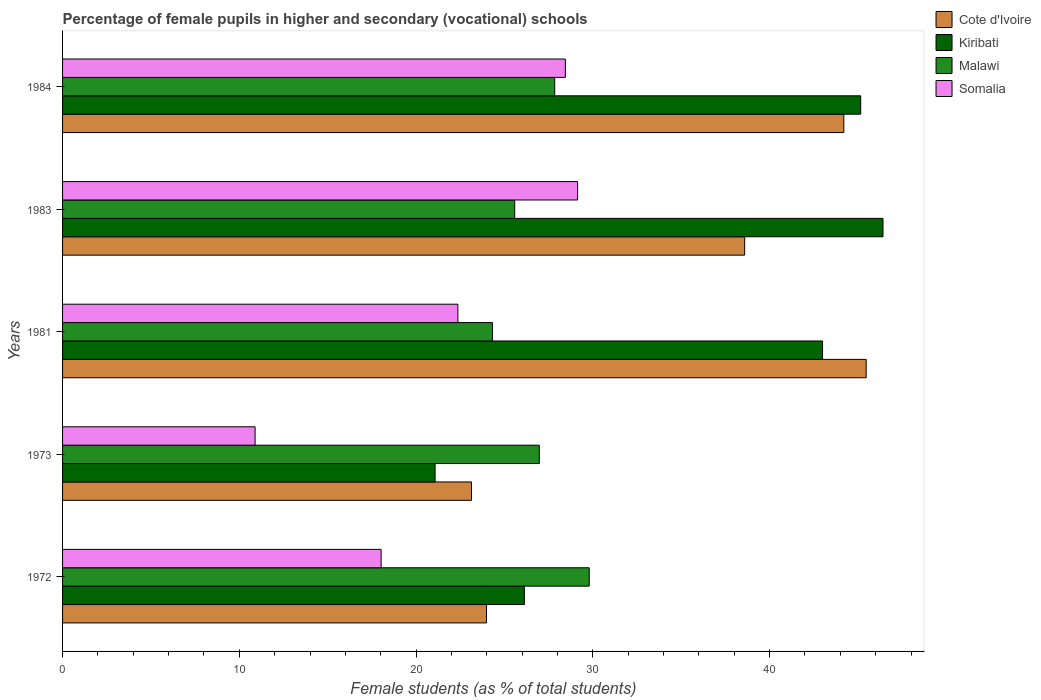How many different coloured bars are there?
Provide a short and direct response. 4. Are the number of bars on each tick of the Y-axis equal?
Ensure brevity in your answer.  Yes. How many bars are there on the 3rd tick from the top?
Provide a short and direct response. 4. How many bars are there on the 3rd tick from the bottom?
Provide a succinct answer. 4. What is the percentage of female pupils in higher and secondary schools in Kiribati in 1981?
Your answer should be compact. 43. Across all years, what is the maximum percentage of female pupils in higher and secondary schools in Kiribati?
Offer a terse response. 46.42. Across all years, what is the minimum percentage of female pupils in higher and secondary schools in Somalia?
Your answer should be very brief. 10.89. What is the total percentage of female pupils in higher and secondary schools in Somalia in the graph?
Your answer should be very brief. 108.86. What is the difference between the percentage of female pupils in higher and secondary schools in Somalia in 1972 and that in 1983?
Ensure brevity in your answer.  -11.12. What is the difference between the percentage of female pupils in higher and secondary schools in Kiribati in 1973 and the percentage of female pupils in higher and secondary schools in Cote d'Ivoire in 1972?
Make the answer very short. -2.91. What is the average percentage of female pupils in higher and secondary schools in Somalia per year?
Offer a very short reply. 21.77. In the year 1973, what is the difference between the percentage of female pupils in higher and secondary schools in Cote d'Ivoire and percentage of female pupils in higher and secondary schools in Somalia?
Provide a succinct answer. 12.24. What is the ratio of the percentage of female pupils in higher and secondary schools in Cote d'Ivoire in 1973 to that in 1981?
Make the answer very short. 0.51. What is the difference between the highest and the second highest percentage of female pupils in higher and secondary schools in Cote d'Ivoire?
Keep it short and to the point. 1.26. What is the difference between the highest and the lowest percentage of female pupils in higher and secondary schools in Kiribati?
Make the answer very short. 25.34. What does the 1st bar from the top in 1981 represents?
Make the answer very short. Somalia. What does the 1st bar from the bottom in 1981 represents?
Make the answer very short. Cote d'Ivoire. Is it the case that in every year, the sum of the percentage of female pupils in higher and secondary schools in Cote d'Ivoire and percentage of female pupils in higher and secondary schools in Somalia is greater than the percentage of female pupils in higher and secondary schools in Malawi?
Your response must be concise. Yes. How many bars are there?
Keep it short and to the point. 20. How many years are there in the graph?
Provide a short and direct response. 5. Are the values on the major ticks of X-axis written in scientific E-notation?
Keep it short and to the point. No. Does the graph contain any zero values?
Offer a very short reply. No. What is the title of the graph?
Ensure brevity in your answer.  Percentage of female pupils in higher and secondary (vocational) schools. Does "Paraguay" appear as one of the legend labels in the graph?
Keep it short and to the point. No. What is the label or title of the X-axis?
Ensure brevity in your answer.  Female students (as % of total students). What is the label or title of the Y-axis?
Your answer should be compact. Years. What is the Female students (as % of total students) of Cote d'Ivoire in 1972?
Ensure brevity in your answer.  23.98. What is the Female students (as % of total students) of Kiribati in 1972?
Ensure brevity in your answer.  26.13. What is the Female students (as % of total students) in Malawi in 1972?
Ensure brevity in your answer.  29.8. What is the Female students (as % of total students) in Somalia in 1972?
Give a very brief answer. 18.02. What is the Female students (as % of total students) in Cote d'Ivoire in 1973?
Give a very brief answer. 23.13. What is the Female students (as % of total students) in Kiribati in 1973?
Offer a very short reply. 21.08. What is the Female students (as % of total students) in Malawi in 1973?
Your answer should be compact. 26.97. What is the Female students (as % of total students) in Somalia in 1973?
Your response must be concise. 10.89. What is the Female students (as % of total students) in Cote d'Ivoire in 1981?
Keep it short and to the point. 45.47. What is the Female students (as % of total students) in Kiribati in 1981?
Your answer should be very brief. 43. What is the Female students (as % of total students) in Malawi in 1981?
Ensure brevity in your answer.  24.32. What is the Female students (as % of total students) of Somalia in 1981?
Provide a short and direct response. 22.36. What is the Female students (as % of total students) of Cote d'Ivoire in 1983?
Make the answer very short. 38.59. What is the Female students (as % of total students) of Kiribati in 1983?
Provide a succinct answer. 46.42. What is the Female students (as % of total students) of Malawi in 1983?
Provide a succinct answer. 25.58. What is the Female students (as % of total students) in Somalia in 1983?
Provide a short and direct response. 29.14. What is the Female students (as % of total students) of Cote d'Ivoire in 1984?
Your answer should be very brief. 44.2. What is the Female students (as % of total students) in Kiribati in 1984?
Ensure brevity in your answer.  45.15. What is the Female students (as % of total students) of Malawi in 1984?
Provide a succinct answer. 27.84. What is the Female students (as % of total students) in Somalia in 1984?
Provide a short and direct response. 28.45. Across all years, what is the maximum Female students (as % of total students) in Cote d'Ivoire?
Provide a short and direct response. 45.47. Across all years, what is the maximum Female students (as % of total students) of Kiribati?
Provide a short and direct response. 46.42. Across all years, what is the maximum Female students (as % of total students) of Malawi?
Keep it short and to the point. 29.8. Across all years, what is the maximum Female students (as % of total students) of Somalia?
Provide a succinct answer. 29.14. Across all years, what is the minimum Female students (as % of total students) in Cote d'Ivoire?
Ensure brevity in your answer.  23.13. Across all years, what is the minimum Female students (as % of total students) in Kiribati?
Your answer should be compact. 21.08. Across all years, what is the minimum Female students (as % of total students) of Malawi?
Your answer should be very brief. 24.32. Across all years, what is the minimum Female students (as % of total students) of Somalia?
Offer a very short reply. 10.89. What is the total Female students (as % of total students) in Cote d'Ivoire in the graph?
Give a very brief answer. 175.37. What is the total Female students (as % of total students) of Kiribati in the graph?
Your answer should be very brief. 181.77. What is the total Female students (as % of total students) of Malawi in the graph?
Your answer should be very brief. 134.51. What is the total Female students (as % of total students) of Somalia in the graph?
Make the answer very short. 108.86. What is the difference between the Female students (as % of total students) in Cote d'Ivoire in 1972 and that in 1973?
Your response must be concise. 0.85. What is the difference between the Female students (as % of total students) in Kiribati in 1972 and that in 1973?
Offer a very short reply. 5.05. What is the difference between the Female students (as % of total students) in Malawi in 1972 and that in 1973?
Your answer should be compact. 2.82. What is the difference between the Female students (as % of total students) of Somalia in 1972 and that in 1973?
Provide a succinct answer. 7.13. What is the difference between the Female students (as % of total students) of Cote d'Ivoire in 1972 and that in 1981?
Offer a very short reply. -21.48. What is the difference between the Female students (as % of total students) in Kiribati in 1972 and that in 1981?
Give a very brief answer. -16.87. What is the difference between the Female students (as % of total students) of Malawi in 1972 and that in 1981?
Make the answer very short. 5.48. What is the difference between the Female students (as % of total students) of Somalia in 1972 and that in 1981?
Keep it short and to the point. -4.34. What is the difference between the Female students (as % of total students) of Cote d'Ivoire in 1972 and that in 1983?
Your response must be concise. -14.61. What is the difference between the Female students (as % of total students) in Kiribati in 1972 and that in 1983?
Keep it short and to the point. -20.29. What is the difference between the Female students (as % of total students) in Malawi in 1972 and that in 1983?
Your response must be concise. 4.22. What is the difference between the Female students (as % of total students) in Somalia in 1972 and that in 1983?
Your response must be concise. -11.12. What is the difference between the Female students (as % of total students) in Cote d'Ivoire in 1972 and that in 1984?
Offer a very short reply. -20.22. What is the difference between the Female students (as % of total students) in Kiribati in 1972 and that in 1984?
Provide a succinct answer. -19.03. What is the difference between the Female students (as % of total students) of Malawi in 1972 and that in 1984?
Your answer should be very brief. 1.95. What is the difference between the Female students (as % of total students) in Somalia in 1972 and that in 1984?
Your answer should be very brief. -10.42. What is the difference between the Female students (as % of total students) of Cote d'Ivoire in 1973 and that in 1981?
Make the answer very short. -22.33. What is the difference between the Female students (as % of total students) in Kiribati in 1973 and that in 1981?
Ensure brevity in your answer.  -21.92. What is the difference between the Female students (as % of total students) in Malawi in 1973 and that in 1981?
Give a very brief answer. 2.65. What is the difference between the Female students (as % of total students) of Somalia in 1973 and that in 1981?
Give a very brief answer. -11.47. What is the difference between the Female students (as % of total students) of Cote d'Ivoire in 1973 and that in 1983?
Offer a terse response. -15.45. What is the difference between the Female students (as % of total students) of Kiribati in 1973 and that in 1983?
Provide a succinct answer. -25.34. What is the difference between the Female students (as % of total students) in Malawi in 1973 and that in 1983?
Provide a short and direct response. 1.39. What is the difference between the Female students (as % of total students) in Somalia in 1973 and that in 1983?
Provide a short and direct response. -18.25. What is the difference between the Female students (as % of total students) in Cote d'Ivoire in 1973 and that in 1984?
Your answer should be compact. -21.07. What is the difference between the Female students (as % of total students) in Kiribati in 1973 and that in 1984?
Your answer should be very brief. -24.08. What is the difference between the Female students (as % of total students) of Malawi in 1973 and that in 1984?
Your response must be concise. -0.87. What is the difference between the Female students (as % of total students) in Somalia in 1973 and that in 1984?
Your answer should be very brief. -17.55. What is the difference between the Female students (as % of total students) of Cote d'Ivoire in 1981 and that in 1983?
Your answer should be very brief. 6.88. What is the difference between the Female students (as % of total students) of Kiribati in 1981 and that in 1983?
Give a very brief answer. -3.42. What is the difference between the Female students (as % of total students) of Malawi in 1981 and that in 1983?
Offer a terse response. -1.26. What is the difference between the Female students (as % of total students) of Somalia in 1981 and that in 1983?
Your answer should be compact. -6.77. What is the difference between the Female students (as % of total students) of Cote d'Ivoire in 1981 and that in 1984?
Ensure brevity in your answer.  1.26. What is the difference between the Female students (as % of total students) of Kiribati in 1981 and that in 1984?
Offer a very short reply. -2.16. What is the difference between the Female students (as % of total students) of Malawi in 1981 and that in 1984?
Give a very brief answer. -3.52. What is the difference between the Female students (as % of total students) in Somalia in 1981 and that in 1984?
Offer a very short reply. -6.08. What is the difference between the Female students (as % of total students) in Cote d'Ivoire in 1983 and that in 1984?
Offer a terse response. -5.61. What is the difference between the Female students (as % of total students) in Kiribati in 1983 and that in 1984?
Provide a succinct answer. 1.26. What is the difference between the Female students (as % of total students) in Malawi in 1983 and that in 1984?
Make the answer very short. -2.26. What is the difference between the Female students (as % of total students) of Somalia in 1983 and that in 1984?
Your response must be concise. 0.69. What is the difference between the Female students (as % of total students) in Cote d'Ivoire in 1972 and the Female students (as % of total students) in Kiribati in 1973?
Keep it short and to the point. 2.91. What is the difference between the Female students (as % of total students) of Cote d'Ivoire in 1972 and the Female students (as % of total students) of Malawi in 1973?
Make the answer very short. -2.99. What is the difference between the Female students (as % of total students) of Cote d'Ivoire in 1972 and the Female students (as % of total students) of Somalia in 1973?
Offer a very short reply. 13.09. What is the difference between the Female students (as % of total students) of Kiribati in 1972 and the Female students (as % of total students) of Malawi in 1973?
Your answer should be compact. -0.84. What is the difference between the Female students (as % of total students) in Kiribati in 1972 and the Female students (as % of total students) in Somalia in 1973?
Your answer should be compact. 15.23. What is the difference between the Female students (as % of total students) in Malawi in 1972 and the Female students (as % of total students) in Somalia in 1973?
Provide a succinct answer. 18.9. What is the difference between the Female students (as % of total students) of Cote d'Ivoire in 1972 and the Female students (as % of total students) of Kiribati in 1981?
Make the answer very short. -19.01. What is the difference between the Female students (as % of total students) of Cote d'Ivoire in 1972 and the Female students (as % of total students) of Malawi in 1981?
Your answer should be very brief. -0.34. What is the difference between the Female students (as % of total students) in Cote d'Ivoire in 1972 and the Female students (as % of total students) in Somalia in 1981?
Make the answer very short. 1.62. What is the difference between the Female students (as % of total students) of Kiribati in 1972 and the Female students (as % of total students) of Malawi in 1981?
Ensure brevity in your answer.  1.81. What is the difference between the Female students (as % of total students) of Kiribati in 1972 and the Female students (as % of total students) of Somalia in 1981?
Offer a very short reply. 3.76. What is the difference between the Female students (as % of total students) in Malawi in 1972 and the Female students (as % of total students) in Somalia in 1981?
Your response must be concise. 7.43. What is the difference between the Female students (as % of total students) of Cote d'Ivoire in 1972 and the Female students (as % of total students) of Kiribati in 1983?
Your response must be concise. -22.43. What is the difference between the Female students (as % of total students) in Cote d'Ivoire in 1972 and the Female students (as % of total students) in Malawi in 1983?
Your answer should be compact. -1.6. What is the difference between the Female students (as % of total students) in Cote d'Ivoire in 1972 and the Female students (as % of total students) in Somalia in 1983?
Your answer should be very brief. -5.16. What is the difference between the Female students (as % of total students) in Kiribati in 1972 and the Female students (as % of total students) in Malawi in 1983?
Your answer should be compact. 0.55. What is the difference between the Female students (as % of total students) of Kiribati in 1972 and the Female students (as % of total students) of Somalia in 1983?
Provide a short and direct response. -3.01. What is the difference between the Female students (as % of total students) in Malawi in 1972 and the Female students (as % of total students) in Somalia in 1983?
Provide a short and direct response. 0.66. What is the difference between the Female students (as % of total students) in Cote d'Ivoire in 1972 and the Female students (as % of total students) in Kiribati in 1984?
Offer a very short reply. -21.17. What is the difference between the Female students (as % of total students) of Cote d'Ivoire in 1972 and the Female students (as % of total students) of Malawi in 1984?
Give a very brief answer. -3.86. What is the difference between the Female students (as % of total students) of Cote d'Ivoire in 1972 and the Female students (as % of total students) of Somalia in 1984?
Your response must be concise. -4.46. What is the difference between the Female students (as % of total students) in Kiribati in 1972 and the Female students (as % of total students) in Malawi in 1984?
Make the answer very short. -1.72. What is the difference between the Female students (as % of total students) of Kiribati in 1972 and the Female students (as % of total students) of Somalia in 1984?
Your answer should be compact. -2.32. What is the difference between the Female students (as % of total students) in Malawi in 1972 and the Female students (as % of total students) in Somalia in 1984?
Your answer should be very brief. 1.35. What is the difference between the Female students (as % of total students) in Cote d'Ivoire in 1973 and the Female students (as % of total students) in Kiribati in 1981?
Ensure brevity in your answer.  -19.86. What is the difference between the Female students (as % of total students) of Cote d'Ivoire in 1973 and the Female students (as % of total students) of Malawi in 1981?
Your answer should be very brief. -1.19. What is the difference between the Female students (as % of total students) of Cote d'Ivoire in 1973 and the Female students (as % of total students) of Somalia in 1981?
Offer a very short reply. 0.77. What is the difference between the Female students (as % of total students) of Kiribati in 1973 and the Female students (as % of total students) of Malawi in 1981?
Offer a very short reply. -3.24. What is the difference between the Female students (as % of total students) of Kiribati in 1973 and the Female students (as % of total students) of Somalia in 1981?
Give a very brief answer. -1.29. What is the difference between the Female students (as % of total students) of Malawi in 1973 and the Female students (as % of total students) of Somalia in 1981?
Offer a terse response. 4.61. What is the difference between the Female students (as % of total students) of Cote d'Ivoire in 1973 and the Female students (as % of total students) of Kiribati in 1983?
Give a very brief answer. -23.28. What is the difference between the Female students (as % of total students) of Cote d'Ivoire in 1973 and the Female students (as % of total students) of Malawi in 1983?
Provide a short and direct response. -2.44. What is the difference between the Female students (as % of total students) of Cote d'Ivoire in 1973 and the Female students (as % of total students) of Somalia in 1983?
Keep it short and to the point. -6. What is the difference between the Female students (as % of total students) in Kiribati in 1973 and the Female students (as % of total students) in Malawi in 1983?
Your answer should be compact. -4.5. What is the difference between the Female students (as % of total students) of Kiribati in 1973 and the Female students (as % of total students) of Somalia in 1983?
Offer a terse response. -8.06. What is the difference between the Female students (as % of total students) of Malawi in 1973 and the Female students (as % of total students) of Somalia in 1983?
Provide a short and direct response. -2.17. What is the difference between the Female students (as % of total students) of Cote d'Ivoire in 1973 and the Female students (as % of total students) of Kiribati in 1984?
Your answer should be very brief. -22.02. What is the difference between the Female students (as % of total students) in Cote d'Ivoire in 1973 and the Female students (as % of total students) in Malawi in 1984?
Your answer should be compact. -4.71. What is the difference between the Female students (as % of total students) of Cote d'Ivoire in 1973 and the Female students (as % of total students) of Somalia in 1984?
Your response must be concise. -5.31. What is the difference between the Female students (as % of total students) of Kiribati in 1973 and the Female students (as % of total students) of Malawi in 1984?
Provide a short and direct response. -6.77. What is the difference between the Female students (as % of total students) of Kiribati in 1973 and the Female students (as % of total students) of Somalia in 1984?
Your response must be concise. -7.37. What is the difference between the Female students (as % of total students) in Malawi in 1973 and the Female students (as % of total students) in Somalia in 1984?
Provide a succinct answer. -1.48. What is the difference between the Female students (as % of total students) of Cote d'Ivoire in 1981 and the Female students (as % of total students) of Kiribati in 1983?
Provide a succinct answer. -0.95. What is the difference between the Female students (as % of total students) in Cote d'Ivoire in 1981 and the Female students (as % of total students) in Malawi in 1983?
Your response must be concise. 19.89. What is the difference between the Female students (as % of total students) of Cote d'Ivoire in 1981 and the Female students (as % of total students) of Somalia in 1983?
Make the answer very short. 16.33. What is the difference between the Female students (as % of total students) in Kiribati in 1981 and the Female students (as % of total students) in Malawi in 1983?
Make the answer very short. 17.42. What is the difference between the Female students (as % of total students) in Kiribati in 1981 and the Female students (as % of total students) in Somalia in 1983?
Provide a short and direct response. 13.86. What is the difference between the Female students (as % of total students) in Malawi in 1981 and the Female students (as % of total students) in Somalia in 1983?
Ensure brevity in your answer.  -4.82. What is the difference between the Female students (as % of total students) of Cote d'Ivoire in 1981 and the Female students (as % of total students) of Kiribati in 1984?
Make the answer very short. 0.31. What is the difference between the Female students (as % of total students) in Cote d'Ivoire in 1981 and the Female students (as % of total students) in Malawi in 1984?
Your response must be concise. 17.62. What is the difference between the Female students (as % of total students) of Cote d'Ivoire in 1981 and the Female students (as % of total students) of Somalia in 1984?
Your answer should be very brief. 17.02. What is the difference between the Female students (as % of total students) in Kiribati in 1981 and the Female students (as % of total students) in Malawi in 1984?
Provide a short and direct response. 15.15. What is the difference between the Female students (as % of total students) in Kiribati in 1981 and the Female students (as % of total students) in Somalia in 1984?
Offer a terse response. 14.55. What is the difference between the Female students (as % of total students) of Malawi in 1981 and the Female students (as % of total students) of Somalia in 1984?
Ensure brevity in your answer.  -4.13. What is the difference between the Female students (as % of total students) in Cote d'Ivoire in 1983 and the Female students (as % of total students) in Kiribati in 1984?
Offer a terse response. -6.57. What is the difference between the Female students (as % of total students) in Cote d'Ivoire in 1983 and the Female students (as % of total students) in Malawi in 1984?
Provide a succinct answer. 10.75. What is the difference between the Female students (as % of total students) of Cote d'Ivoire in 1983 and the Female students (as % of total students) of Somalia in 1984?
Keep it short and to the point. 10.14. What is the difference between the Female students (as % of total students) of Kiribati in 1983 and the Female students (as % of total students) of Malawi in 1984?
Provide a short and direct response. 18.57. What is the difference between the Female students (as % of total students) in Kiribati in 1983 and the Female students (as % of total students) in Somalia in 1984?
Your answer should be compact. 17.97. What is the difference between the Female students (as % of total students) of Malawi in 1983 and the Female students (as % of total students) of Somalia in 1984?
Keep it short and to the point. -2.87. What is the average Female students (as % of total students) of Cote d'Ivoire per year?
Your answer should be compact. 35.07. What is the average Female students (as % of total students) in Kiribati per year?
Offer a terse response. 36.35. What is the average Female students (as % of total students) in Malawi per year?
Ensure brevity in your answer.  26.9. What is the average Female students (as % of total students) in Somalia per year?
Your answer should be compact. 21.77. In the year 1972, what is the difference between the Female students (as % of total students) of Cote d'Ivoire and Female students (as % of total students) of Kiribati?
Keep it short and to the point. -2.14. In the year 1972, what is the difference between the Female students (as % of total students) of Cote d'Ivoire and Female students (as % of total students) of Malawi?
Give a very brief answer. -5.81. In the year 1972, what is the difference between the Female students (as % of total students) of Cote d'Ivoire and Female students (as % of total students) of Somalia?
Provide a short and direct response. 5.96. In the year 1972, what is the difference between the Female students (as % of total students) in Kiribati and Female students (as % of total students) in Malawi?
Provide a succinct answer. -3.67. In the year 1972, what is the difference between the Female students (as % of total students) in Kiribati and Female students (as % of total students) in Somalia?
Ensure brevity in your answer.  8.1. In the year 1972, what is the difference between the Female students (as % of total students) of Malawi and Female students (as % of total students) of Somalia?
Provide a short and direct response. 11.77. In the year 1973, what is the difference between the Female students (as % of total students) in Cote d'Ivoire and Female students (as % of total students) in Kiribati?
Provide a short and direct response. 2.06. In the year 1973, what is the difference between the Female students (as % of total students) in Cote d'Ivoire and Female students (as % of total students) in Malawi?
Your answer should be very brief. -3.84. In the year 1973, what is the difference between the Female students (as % of total students) in Cote d'Ivoire and Female students (as % of total students) in Somalia?
Your response must be concise. 12.24. In the year 1973, what is the difference between the Female students (as % of total students) in Kiribati and Female students (as % of total students) in Malawi?
Provide a succinct answer. -5.89. In the year 1973, what is the difference between the Female students (as % of total students) in Kiribati and Female students (as % of total students) in Somalia?
Your answer should be compact. 10.18. In the year 1973, what is the difference between the Female students (as % of total students) of Malawi and Female students (as % of total students) of Somalia?
Offer a terse response. 16.08. In the year 1981, what is the difference between the Female students (as % of total students) of Cote d'Ivoire and Female students (as % of total students) of Kiribati?
Provide a succinct answer. 2.47. In the year 1981, what is the difference between the Female students (as % of total students) of Cote d'Ivoire and Female students (as % of total students) of Malawi?
Provide a short and direct response. 21.15. In the year 1981, what is the difference between the Female students (as % of total students) of Cote d'Ivoire and Female students (as % of total students) of Somalia?
Ensure brevity in your answer.  23.1. In the year 1981, what is the difference between the Female students (as % of total students) of Kiribati and Female students (as % of total students) of Malawi?
Ensure brevity in your answer.  18.68. In the year 1981, what is the difference between the Female students (as % of total students) of Kiribati and Female students (as % of total students) of Somalia?
Ensure brevity in your answer.  20.63. In the year 1981, what is the difference between the Female students (as % of total students) of Malawi and Female students (as % of total students) of Somalia?
Keep it short and to the point. 1.96. In the year 1983, what is the difference between the Female students (as % of total students) of Cote d'Ivoire and Female students (as % of total students) of Kiribati?
Your response must be concise. -7.83. In the year 1983, what is the difference between the Female students (as % of total students) of Cote d'Ivoire and Female students (as % of total students) of Malawi?
Offer a very short reply. 13.01. In the year 1983, what is the difference between the Female students (as % of total students) in Cote d'Ivoire and Female students (as % of total students) in Somalia?
Provide a succinct answer. 9.45. In the year 1983, what is the difference between the Female students (as % of total students) in Kiribati and Female students (as % of total students) in Malawi?
Make the answer very short. 20.84. In the year 1983, what is the difference between the Female students (as % of total students) in Kiribati and Female students (as % of total students) in Somalia?
Give a very brief answer. 17.28. In the year 1983, what is the difference between the Female students (as % of total students) of Malawi and Female students (as % of total students) of Somalia?
Your answer should be compact. -3.56. In the year 1984, what is the difference between the Female students (as % of total students) in Cote d'Ivoire and Female students (as % of total students) in Kiribati?
Ensure brevity in your answer.  -0.95. In the year 1984, what is the difference between the Female students (as % of total students) of Cote d'Ivoire and Female students (as % of total students) of Malawi?
Your answer should be compact. 16.36. In the year 1984, what is the difference between the Female students (as % of total students) of Cote d'Ivoire and Female students (as % of total students) of Somalia?
Your response must be concise. 15.75. In the year 1984, what is the difference between the Female students (as % of total students) in Kiribati and Female students (as % of total students) in Malawi?
Offer a very short reply. 17.31. In the year 1984, what is the difference between the Female students (as % of total students) in Kiribati and Female students (as % of total students) in Somalia?
Make the answer very short. 16.71. In the year 1984, what is the difference between the Female students (as % of total students) of Malawi and Female students (as % of total students) of Somalia?
Give a very brief answer. -0.6. What is the ratio of the Female students (as % of total students) in Cote d'Ivoire in 1972 to that in 1973?
Your answer should be very brief. 1.04. What is the ratio of the Female students (as % of total students) of Kiribati in 1972 to that in 1973?
Your answer should be very brief. 1.24. What is the ratio of the Female students (as % of total students) of Malawi in 1972 to that in 1973?
Your answer should be very brief. 1.1. What is the ratio of the Female students (as % of total students) in Somalia in 1972 to that in 1973?
Offer a terse response. 1.65. What is the ratio of the Female students (as % of total students) in Cote d'Ivoire in 1972 to that in 1981?
Offer a terse response. 0.53. What is the ratio of the Female students (as % of total students) in Kiribati in 1972 to that in 1981?
Ensure brevity in your answer.  0.61. What is the ratio of the Female students (as % of total students) in Malawi in 1972 to that in 1981?
Your answer should be very brief. 1.23. What is the ratio of the Female students (as % of total students) in Somalia in 1972 to that in 1981?
Offer a very short reply. 0.81. What is the ratio of the Female students (as % of total students) of Cote d'Ivoire in 1972 to that in 1983?
Offer a terse response. 0.62. What is the ratio of the Female students (as % of total students) of Kiribati in 1972 to that in 1983?
Offer a terse response. 0.56. What is the ratio of the Female students (as % of total students) of Malawi in 1972 to that in 1983?
Your answer should be compact. 1.16. What is the ratio of the Female students (as % of total students) in Somalia in 1972 to that in 1983?
Your answer should be very brief. 0.62. What is the ratio of the Female students (as % of total students) of Cote d'Ivoire in 1972 to that in 1984?
Provide a succinct answer. 0.54. What is the ratio of the Female students (as % of total students) in Kiribati in 1972 to that in 1984?
Provide a succinct answer. 0.58. What is the ratio of the Female students (as % of total students) of Malawi in 1972 to that in 1984?
Keep it short and to the point. 1.07. What is the ratio of the Female students (as % of total students) of Somalia in 1972 to that in 1984?
Make the answer very short. 0.63. What is the ratio of the Female students (as % of total students) of Cote d'Ivoire in 1973 to that in 1981?
Give a very brief answer. 0.51. What is the ratio of the Female students (as % of total students) in Kiribati in 1973 to that in 1981?
Make the answer very short. 0.49. What is the ratio of the Female students (as % of total students) in Malawi in 1973 to that in 1981?
Give a very brief answer. 1.11. What is the ratio of the Female students (as % of total students) in Somalia in 1973 to that in 1981?
Keep it short and to the point. 0.49. What is the ratio of the Female students (as % of total students) of Cote d'Ivoire in 1973 to that in 1983?
Your answer should be very brief. 0.6. What is the ratio of the Female students (as % of total students) in Kiribati in 1973 to that in 1983?
Keep it short and to the point. 0.45. What is the ratio of the Female students (as % of total students) of Malawi in 1973 to that in 1983?
Provide a succinct answer. 1.05. What is the ratio of the Female students (as % of total students) of Somalia in 1973 to that in 1983?
Ensure brevity in your answer.  0.37. What is the ratio of the Female students (as % of total students) in Cote d'Ivoire in 1973 to that in 1984?
Your response must be concise. 0.52. What is the ratio of the Female students (as % of total students) in Kiribati in 1973 to that in 1984?
Give a very brief answer. 0.47. What is the ratio of the Female students (as % of total students) of Malawi in 1973 to that in 1984?
Offer a terse response. 0.97. What is the ratio of the Female students (as % of total students) of Somalia in 1973 to that in 1984?
Provide a short and direct response. 0.38. What is the ratio of the Female students (as % of total students) in Cote d'Ivoire in 1981 to that in 1983?
Offer a very short reply. 1.18. What is the ratio of the Female students (as % of total students) in Kiribati in 1981 to that in 1983?
Your response must be concise. 0.93. What is the ratio of the Female students (as % of total students) in Malawi in 1981 to that in 1983?
Your answer should be very brief. 0.95. What is the ratio of the Female students (as % of total students) in Somalia in 1981 to that in 1983?
Your answer should be compact. 0.77. What is the ratio of the Female students (as % of total students) of Cote d'Ivoire in 1981 to that in 1984?
Offer a very short reply. 1.03. What is the ratio of the Female students (as % of total students) of Kiribati in 1981 to that in 1984?
Ensure brevity in your answer.  0.95. What is the ratio of the Female students (as % of total students) in Malawi in 1981 to that in 1984?
Give a very brief answer. 0.87. What is the ratio of the Female students (as % of total students) in Somalia in 1981 to that in 1984?
Provide a succinct answer. 0.79. What is the ratio of the Female students (as % of total students) in Cote d'Ivoire in 1983 to that in 1984?
Provide a short and direct response. 0.87. What is the ratio of the Female students (as % of total students) in Kiribati in 1983 to that in 1984?
Your answer should be very brief. 1.03. What is the ratio of the Female students (as % of total students) in Malawi in 1983 to that in 1984?
Provide a short and direct response. 0.92. What is the ratio of the Female students (as % of total students) in Somalia in 1983 to that in 1984?
Make the answer very short. 1.02. What is the difference between the highest and the second highest Female students (as % of total students) in Cote d'Ivoire?
Offer a very short reply. 1.26. What is the difference between the highest and the second highest Female students (as % of total students) in Kiribati?
Offer a terse response. 1.26. What is the difference between the highest and the second highest Female students (as % of total students) in Malawi?
Ensure brevity in your answer.  1.95. What is the difference between the highest and the second highest Female students (as % of total students) of Somalia?
Provide a short and direct response. 0.69. What is the difference between the highest and the lowest Female students (as % of total students) in Cote d'Ivoire?
Provide a short and direct response. 22.33. What is the difference between the highest and the lowest Female students (as % of total students) in Kiribati?
Offer a very short reply. 25.34. What is the difference between the highest and the lowest Female students (as % of total students) of Malawi?
Your response must be concise. 5.48. What is the difference between the highest and the lowest Female students (as % of total students) in Somalia?
Your answer should be very brief. 18.25. 